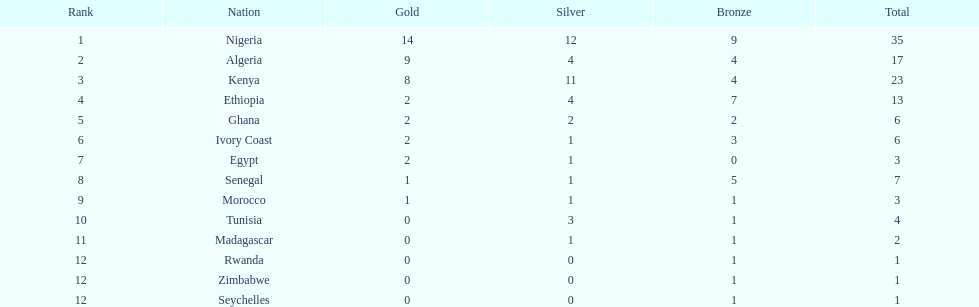Could you help me parse every detail presented in this table? {'header': ['Rank', 'Nation', 'Gold', 'Silver', 'Bronze', 'Total'], 'rows': [['1', 'Nigeria', '14', '12', '9', '35'], ['2', 'Algeria', '9', '4', '4', '17'], ['3', 'Kenya', '8', '11', '4', '23'], ['4', 'Ethiopia', '2', '4', '7', '13'], ['5', 'Ghana', '2', '2', '2', '6'], ['6', 'Ivory Coast', '2', '1', '3', '6'], ['7', 'Egypt', '2', '1', '0', '3'], ['8', 'Senegal', '1', '1', '5', '7'], ['9', 'Morocco', '1', '1', '1', '3'], ['10', 'Tunisia', '0', '3', '1', '4'], ['11', 'Madagascar', '0', '1', '1', '2'], ['12', 'Rwanda', '0', '0', '1', '1'], ['12', 'Zimbabwe', '0', '0', '1', '1'], ['12', 'Seychelles', '0', '0', '1', '1']]} How many silver medals did kenya earn? 11. 